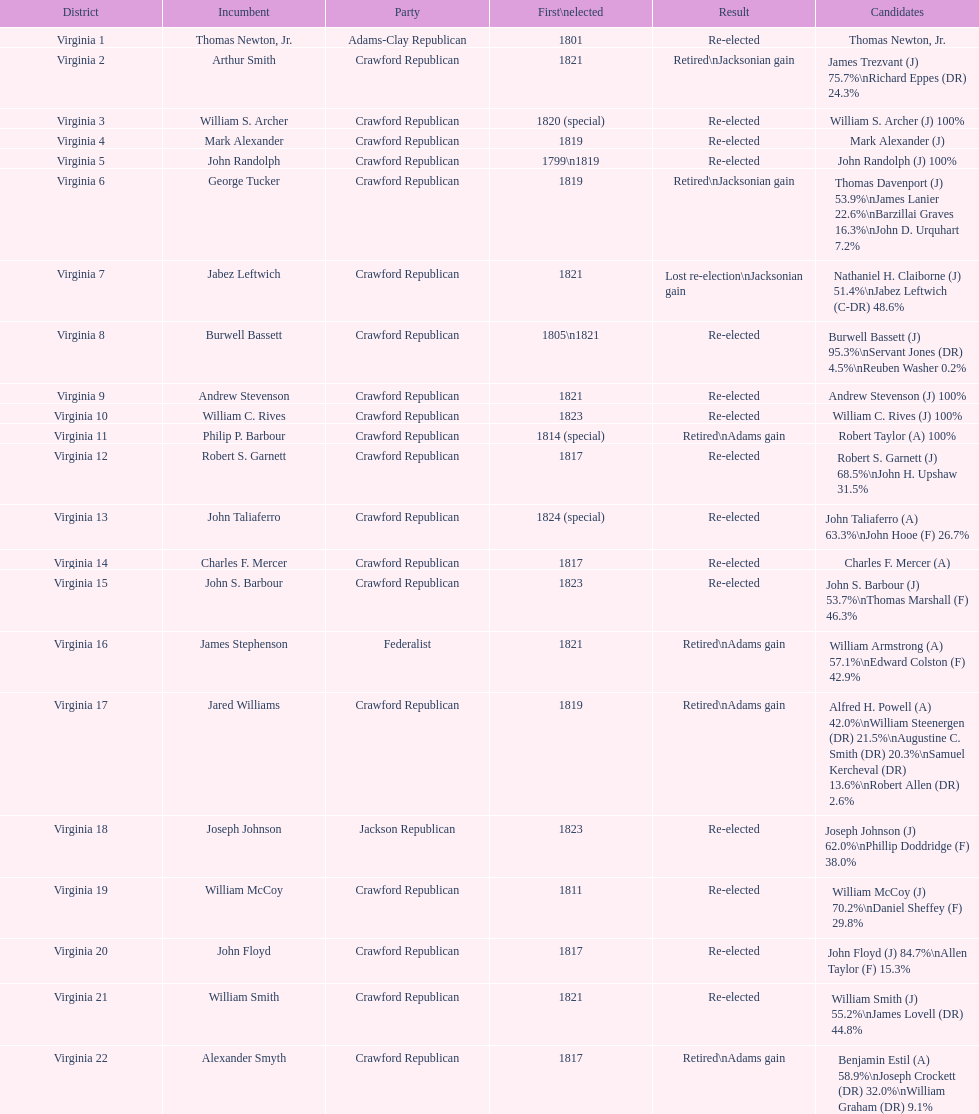Tell me the number of people first elected in 1817. 4. 